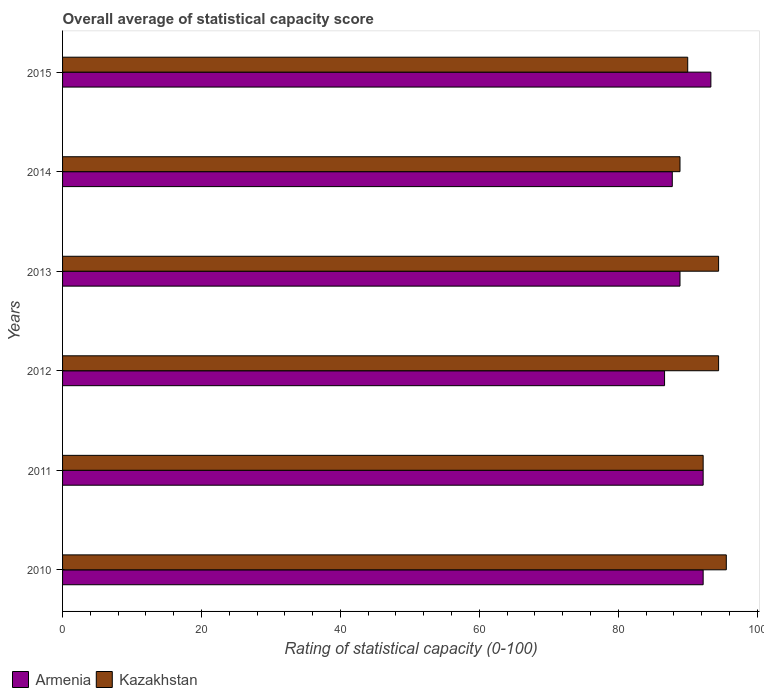How many different coloured bars are there?
Your answer should be very brief. 2. Are the number of bars per tick equal to the number of legend labels?
Provide a short and direct response. Yes. What is the label of the 6th group of bars from the top?
Give a very brief answer. 2010. In how many cases, is the number of bars for a given year not equal to the number of legend labels?
Give a very brief answer. 0. What is the rating of statistical capacity in Armenia in 2010?
Your response must be concise. 92.22. Across all years, what is the maximum rating of statistical capacity in Kazakhstan?
Offer a very short reply. 95.56. Across all years, what is the minimum rating of statistical capacity in Kazakhstan?
Offer a terse response. 88.89. In which year was the rating of statistical capacity in Armenia maximum?
Your answer should be very brief. 2015. In which year was the rating of statistical capacity in Armenia minimum?
Your response must be concise. 2012. What is the total rating of statistical capacity in Armenia in the graph?
Give a very brief answer. 541.11. What is the difference between the rating of statistical capacity in Armenia in 2013 and that in 2014?
Provide a short and direct response. 1.11. What is the difference between the rating of statistical capacity in Kazakhstan in 2013 and the rating of statistical capacity in Armenia in 2015?
Make the answer very short. 1.11. What is the average rating of statistical capacity in Kazakhstan per year?
Provide a succinct answer. 92.59. In the year 2013, what is the difference between the rating of statistical capacity in Kazakhstan and rating of statistical capacity in Armenia?
Provide a short and direct response. 5.56. In how many years, is the rating of statistical capacity in Kazakhstan greater than 52 ?
Ensure brevity in your answer.  6. What is the ratio of the rating of statistical capacity in Kazakhstan in 2011 to that in 2012?
Your answer should be very brief. 0.98. Is the rating of statistical capacity in Armenia in 2012 less than that in 2014?
Keep it short and to the point. Yes. What is the difference between the highest and the second highest rating of statistical capacity in Kazakhstan?
Keep it short and to the point. 1.11. What is the difference between the highest and the lowest rating of statistical capacity in Armenia?
Offer a very short reply. 6.67. Is the sum of the rating of statistical capacity in Kazakhstan in 2011 and 2012 greater than the maximum rating of statistical capacity in Armenia across all years?
Give a very brief answer. Yes. What does the 2nd bar from the top in 2010 represents?
Make the answer very short. Armenia. What does the 2nd bar from the bottom in 2013 represents?
Ensure brevity in your answer.  Kazakhstan. How many bars are there?
Provide a succinct answer. 12. What is the difference between two consecutive major ticks on the X-axis?
Give a very brief answer. 20. Are the values on the major ticks of X-axis written in scientific E-notation?
Give a very brief answer. No. Where does the legend appear in the graph?
Your response must be concise. Bottom left. How many legend labels are there?
Offer a terse response. 2. How are the legend labels stacked?
Your answer should be very brief. Horizontal. What is the title of the graph?
Your answer should be very brief. Overall average of statistical capacity score. Does "Aruba" appear as one of the legend labels in the graph?
Provide a succinct answer. No. What is the label or title of the X-axis?
Give a very brief answer. Rating of statistical capacity (0-100). What is the label or title of the Y-axis?
Ensure brevity in your answer.  Years. What is the Rating of statistical capacity (0-100) of Armenia in 2010?
Keep it short and to the point. 92.22. What is the Rating of statistical capacity (0-100) of Kazakhstan in 2010?
Your response must be concise. 95.56. What is the Rating of statistical capacity (0-100) of Armenia in 2011?
Offer a very short reply. 92.22. What is the Rating of statistical capacity (0-100) of Kazakhstan in 2011?
Provide a succinct answer. 92.22. What is the Rating of statistical capacity (0-100) in Armenia in 2012?
Offer a very short reply. 86.67. What is the Rating of statistical capacity (0-100) of Kazakhstan in 2012?
Your answer should be very brief. 94.44. What is the Rating of statistical capacity (0-100) of Armenia in 2013?
Offer a very short reply. 88.89. What is the Rating of statistical capacity (0-100) in Kazakhstan in 2013?
Offer a terse response. 94.44. What is the Rating of statistical capacity (0-100) of Armenia in 2014?
Your answer should be compact. 87.78. What is the Rating of statistical capacity (0-100) of Kazakhstan in 2014?
Make the answer very short. 88.89. What is the Rating of statistical capacity (0-100) of Armenia in 2015?
Your answer should be very brief. 93.33. What is the Rating of statistical capacity (0-100) in Kazakhstan in 2015?
Make the answer very short. 90. Across all years, what is the maximum Rating of statistical capacity (0-100) in Armenia?
Your answer should be very brief. 93.33. Across all years, what is the maximum Rating of statistical capacity (0-100) of Kazakhstan?
Give a very brief answer. 95.56. Across all years, what is the minimum Rating of statistical capacity (0-100) in Armenia?
Provide a succinct answer. 86.67. Across all years, what is the minimum Rating of statistical capacity (0-100) in Kazakhstan?
Your answer should be very brief. 88.89. What is the total Rating of statistical capacity (0-100) of Armenia in the graph?
Your answer should be compact. 541.11. What is the total Rating of statistical capacity (0-100) of Kazakhstan in the graph?
Offer a terse response. 555.56. What is the difference between the Rating of statistical capacity (0-100) in Armenia in 2010 and that in 2012?
Offer a very short reply. 5.56. What is the difference between the Rating of statistical capacity (0-100) in Armenia in 2010 and that in 2013?
Your answer should be compact. 3.33. What is the difference between the Rating of statistical capacity (0-100) of Kazakhstan in 2010 and that in 2013?
Your response must be concise. 1.11. What is the difference between the Rating of statistical capacity (0-100) of Armenia in 2010 and that in 2014?
Ensure brevity in your answer.  4.44. What is the difference between the Rating of statistical capacity (0-100) of Kazakhstan in 2010 and that in 2014?
Ensure brevity in your answer.  6.67. What is the difference between the Rating of statistical capacity (0-100) in Armenia in 2010 and that in 2015?
Give a very brief answer. -1.11. What is the difference between the Rating of statistical capacity (0-100) in Kazakhstan in 2010 and that in 2015?
Ensure brevity in your answer.  5.56. What is the difference between the Rating of statistical capacity (0-100) in Armenia in 2011 and that in 2012?
Give a very brief answer. 5.56. What is the difference between the Rating of statistical capacity (0-100) of Kazakhstan in 2011 and that in 2012?
Your answer should be very brief. -2.22. What is the difference between the Rating of statistical capacity (0-100) of Armenia in 2011 and that in 2013?
Ensure brevity in your answer.  3.33. What is the difference between the Rating of statistical capacity (0-100) of Kazakhstan in 2011 and that in 2013?
Provide a succinct answer. -2.22. What is the difference between the Rating of statistical capacity (0-100) in Armenia in 2011 and that in 2014?
Your answer should be compact. 4.44. What is the difference between the Rating of statistical capacity (0-100) of Armenia in 2011 and that in 2015?
Keep it short and to the point. -1.11. What is the difference between the Rating of statistical capacity (0-100) of Kazakhstan in 2011 and that in 2015?
Offer a terse response. 2.22. What is the difference between the Rating of statistical capacity (0-100) of Armenia in 2012 and that in 2013?
Offer a very short reply. -2.22. What is the difference between the Rating of statistical capacity (0-100) of Kazakhstan in 2012 and that in 2013?
Offer a very short reply. 0. What is the difference between the Rating of statistical capacity (0-100) of Armenia in 2012 and that in 2014?
Give a very brief answer. -1.11. What is the difference between the Rating of statistical capacity (0-100) in Kazakhstan in 2012 and that in 2014?
Offer a terse response. 5.56. What is the difference between the Rating of statistical capacity (0-100) in Armenia in 2012 and that in 2015?
Your response must be concise. -6.67. What is the difference between the Rating of statistical capacity (0-100) of Kazakhstan in 2012 and that in 2015?
Ensure brevity in your answer.  4.44. What is the difference between the Rating of statistical capacity (0-100) of Armenia in 2013 and that in 2014?
Keep it short and to the point. 1.11. What is the difference between the Rating of statistical capacity (0-100) of Kazakhstan in 2013 and that in 2014?
Offer a very short reply. 5.56. What is the difference between the Rating of statistical capacity (0-100) of Armenia in 2013 and that in 2015?
Keep it short and to the point. -4.44. What is the difference between the Rating of statistical capacity (0-100) of Kazakhstan in 2013 and that in 2015?
Your response must be concise. 4.44. What is the difference between the Rating of statistical capacity (0-100) of Armenia in 2014 and that in 2015?
Ensure brevity in your answer.  -5.56. What is the difference between the Rating of statistical capacity (0-100) of Kazakhstan in 2014 and that in 2015?
Your response must be concise. -1.11. What is the difference between the Rating of statistical capacity (0-100) of Armenia in 2010 and the Rating of statistical capacity (0-100) of Kazakhstan in 2011?
Offer a terse response. 0. What is the difference between the Rating of statistical capacity (0-100) of Armenia in 2010 and the Rating of statistical capacity (0-100) of Kazakhstan in 2012?
Provide a short and direct response. -2.22. What is the difference between the Rating of statistical capacity (0-100) of Armenia in 2010 and the Rating of statistical capacity (0-100) of Kazakhstan in 2013?
Make the answer very short. -2.22. What is the difference between the Rating of statistical capacity (0-100) in Armenia in 2010 and the Rating of statistical capacity (0-100) in Kazakhstan in 2015?
Offer a terse response. 2.22. What is the difference between the Rating of statistical capacity (0-100) in Armenia in 2011 and the Rating of statistical capacity (0-100) in Kazakhstan in 2012?
Offer a terse response. -2.22. What is the difference between the Rating of statistical capacity (0-100) in Armenia in 2011 and the Rating of statistical capacity (0-100) in Kazakhstan in 2013?
Offer a terse response. -2.22. What is the difference between the Rating of statistical capacity (0-100) in Armenia in 2011 and the Rating of statistical capacity (0-100) in Kazakhstan in 2014?
Give a very brief answer. 3.33. What is the difference between the Rating of statistical capacity (0-100) of Armenia in 2011 and the Rating of statistical capacity (0-100) of Kazakhstan in 2015?
Offer a terse response. 2.22. What is the difference between the Rating of statistical capacity (0-100) of Armenia in 2012 and the Rating of statistical capacity (0-100) of Kazakhstan in 2013?
Offer a terse response. -7.78. What is the difference between the Rating of statistical capacity (0-100) in Armenia in 2012 and the Rating of statistical capacity (0-100) in Kazakhstan in 2014?
Offer a terse response. -2.22. What is the difference between the Rating of statistical capacity (0-100) in Armenia in 2012 and the Rating of statistical capacity (0-100) in Kazakhstan in 2015?
Your response must be concise. -3.33. What is the difference between the Rating of statistical capacity (0-100) of Armenia in 2013 and the Rating of statistical capacity (0-100) of Kazakhstan in 2014?
Provide a short and direct response. 0. What is the difference between the Rating of statistical capacity (0-100) in Armenia in 2013 and the Rating of statistical capacity (0-100) in Kazakhstan in 2015?
Offer a very short reply. -1.11. What is the difference between the Rating of statistical capacity (0-100) in Armenia in 2014 and the Rating of statistical capacity (0-100) in Kazakhstan in 2015?
Offer a very short reply. -2.22. What is the average Rating of statistical capacity (0-100) of Armenia per year?
Keep it short and to the point. 90.19. What is the average Rating of statistical capacity (0-100) in Kazakhstan per year?
Give a very brief answer. 92.59. In the year 2010, what is the difference between the Rating of statistical capacity (0-100) in Armenia and Rating of statistical capacity (0-100) in Kazakhstan?
Make the answer very short. -3.33. In the year 2012, what is the difference between the Rating of statistical capacity (0-100) of Armenia and Rating of statistical capacity (0-100) of Kazakhstan?
Offer a very short reply. -7.78. In the year 2013, what is the difference between the Rating of statistical capacity (0-100) in Armenia and Rating of statistical capacity (0-100) in Kazakhstan?
Offer a terse response. -5.56. In the year 2014, what is the difference between the Rating of statistical capacity (0-100) in Armenia and Rating of statistical capacity (0-100) in Kazakhstan?
Ensure brevity in your answer.  -1.11. In the year 2015, what is the difference between the Rating of statistical capacity (0-100) in Armenia and Rating of statistical capacity (0-100) in Kazakhstan?
Provide a short and direct response. 3.33. What is the ratio of the Rating of statistical capacity (0-100) in Armenia in 2010 to that in 2011?
Your response must be concise. 1. What is the ratio of the Rating of statistical capacity (0-100) of Kazakhstan in 2010 to that in 2011?
Provide a succinct answer. 1.04. What is the ratio of the Rating of statistical capacity (0-100) of Armenia in 2010 to that in 2012?
Keep it short and to the point. 1.06. What is the ratio of the Rating of statistical capacity (0-100) in Kazakhstan in 2010 to that in 2012?
Provide a succinct answer. 1.01. What is the ratio of the Rating of statistical capacity (0-100) of Armenia in 2010 to that in 2013?
Provide a succinct answer. 1.04. What is the ratio of the Rating of statistical capacity (0-100) in Kazakhstan in 2010 to that in 2013?
Provide a short and direct response. 1.01. What is the ratio of the Rating of statistical capacity (0-100) of Armenia in 2010 to that in 2014?
Ensure brevity in your answer.  1.05. What is the ratio of the Rating of statistical capacity (0-100) in Kazakhstan in 2010 to that in 2014?
Give a very brief answer. 1.07. What is the ratio of the Rating of statistical capacity (0-100) in Kazakhstan in 2010 to that in 2015?
Make the answer very short. 1.06. What is the ratio of the Rating of statistical capacity (0-100) in Armenia in 2011 to that in 2012?
Provide a succinct answer. 1.06. What is the ratio of the Rating of statistical capacity (0-100) in Kazakhstan in 2011 to that in 2012?
Provide a succinct answer. 0.98. What is the ratio of the Rating of statistical capacity (0-100) of Armenia in 2011 to that in 2013?
Your answer should be compact. 1.04. What is the ratio of the Rating of statistical capacity (0-100) in Kazakhstan in 2011 to that in 2013?
Your answer should be very brief. 0.98. What is the ratio of the Rating of statistical capacity (0-100) in Armenia in 2011 to that in 2014?
Give a very brief answer. 1.05. What is the ratio of the Rating of statistical capacity (0-100) of Kazakhstan in 2011 to that in 2014?
Offer a very short reply. 1.04. What is the ratio of the Rating of statistical capacity (0-100) in Armenia in 2011 to that in 2015?
Provide a short and direct response. 0.99. What is the ratio of the Rating of statistical capacity (0-100) of Kazakhstan in 2011 to that in 2015?
Your answer should be very brief. 1.02. What is the ratio of the Rating of statistical capacity (0-100) in Armenia in 2012 to that in 2013?
Your answer should be compact. 0.97. What is the ratio of the Rating of statistical capacity (0-100) of Kazakhstan in 2012 to that in 2013?
Offer a very short reply. 1. What is the ratio of the Rating of statistical capacity (0-100) of Armenia in 2012 to that in 2014?
Provide a short and direct response. 0.99. What is the ratio of the Rating of statistical capacity (0-100) of Armenia in 2012 to that in 2015?
Provide a succinct answer. 0.93. What is the ratio of the Rating of statistical capacity (0-100) in Kazakhstan in 2012 to that in 2015?
Make the answer very short. 1.05. What is the ratio of the Rating of statistical capacity (0-100) of Armenia in 2013 to that in 2014?
Your answer should be very brief. 1.01. What is the ratio of the Rating of statistical capacity (0-100) of Kazakhstan in 2013 to that in 2014?
Your response must be concise. 1.06. What is the ratio of the Rating of statistical capacity (0-100) of Armenia in 2013 to that in 2015?
Keep it short and to the point. 0.95. What is the ratio of the Rating of statistical capacity (0-100) of Kazakhstan in 2013 to that in 2015?
Provide a succinct answer. 1.05. What is the ratio of the Rating of statistical capacity (0-100) in Armenia in 2014 to that in 2015?
Provide a succinct answer. 0.94. What is the ratio of the Rating of statistical capacity (0-100) in Kazakhstan in 2014 to that in 2015?
Provide a succinct answer. 0.99. What is the difference between the highest and the second highest Rating of statistical capacity (0-100) in Armenia?
Ensure brevity in your answer.  1.11. What is the difference between the highest and the second highest Rating of statistical capacity (0-100) in Kazakhstan?
Offer a very short reply. 1.11. What is the difference between the highest and the lowest Rating of statistical capacity (0-100) in Armenia?
Keep it short and to the point. 6.67. 